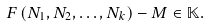<formula> <loc_0><loc_0><loc_500><loc_500>F \left ( N _ { 1 } , N _ { 2 } , \dots , N _ { k } \right ) - M \in \mathbb { K } .</formula> 